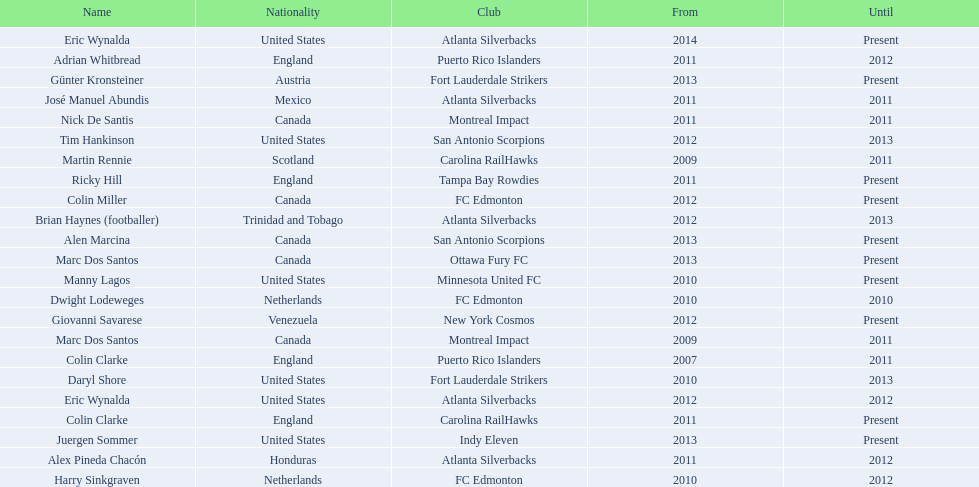What were all the coaches who were coaching in 2010? Martin Rennie, Dwight Lodeweges, Harry Sinkgraven, Daryl Shore, Manny Lagos, Marc Dos Santos, Colin Clarke. Which of the 2010 coaches were not born in north america? Martin Rennie, Dwight Lodeweges, Harry Sinkgraven, Colin Clarke. Which coaches that were coaching in 2010 and were not from north america did not coach for fc edmonton? Martin Rennie, Colin Clarke. What coach did not coach for fc edmonton in 2010 and was not north american nationality had the shortened career as a coach? Martin Rennie. 